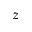<formula> <loc_0><loc_0><loc_500><loc_500>z</formula> 